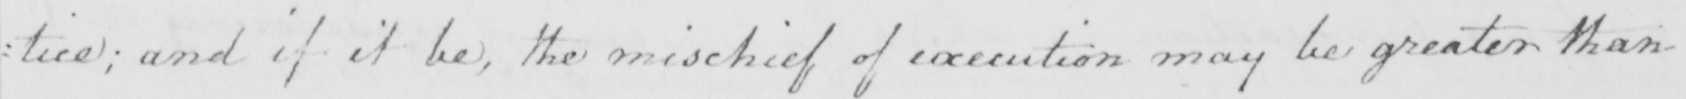What does this handwritten line say? tice ; and if it be , the mischief of execution may be greater than 